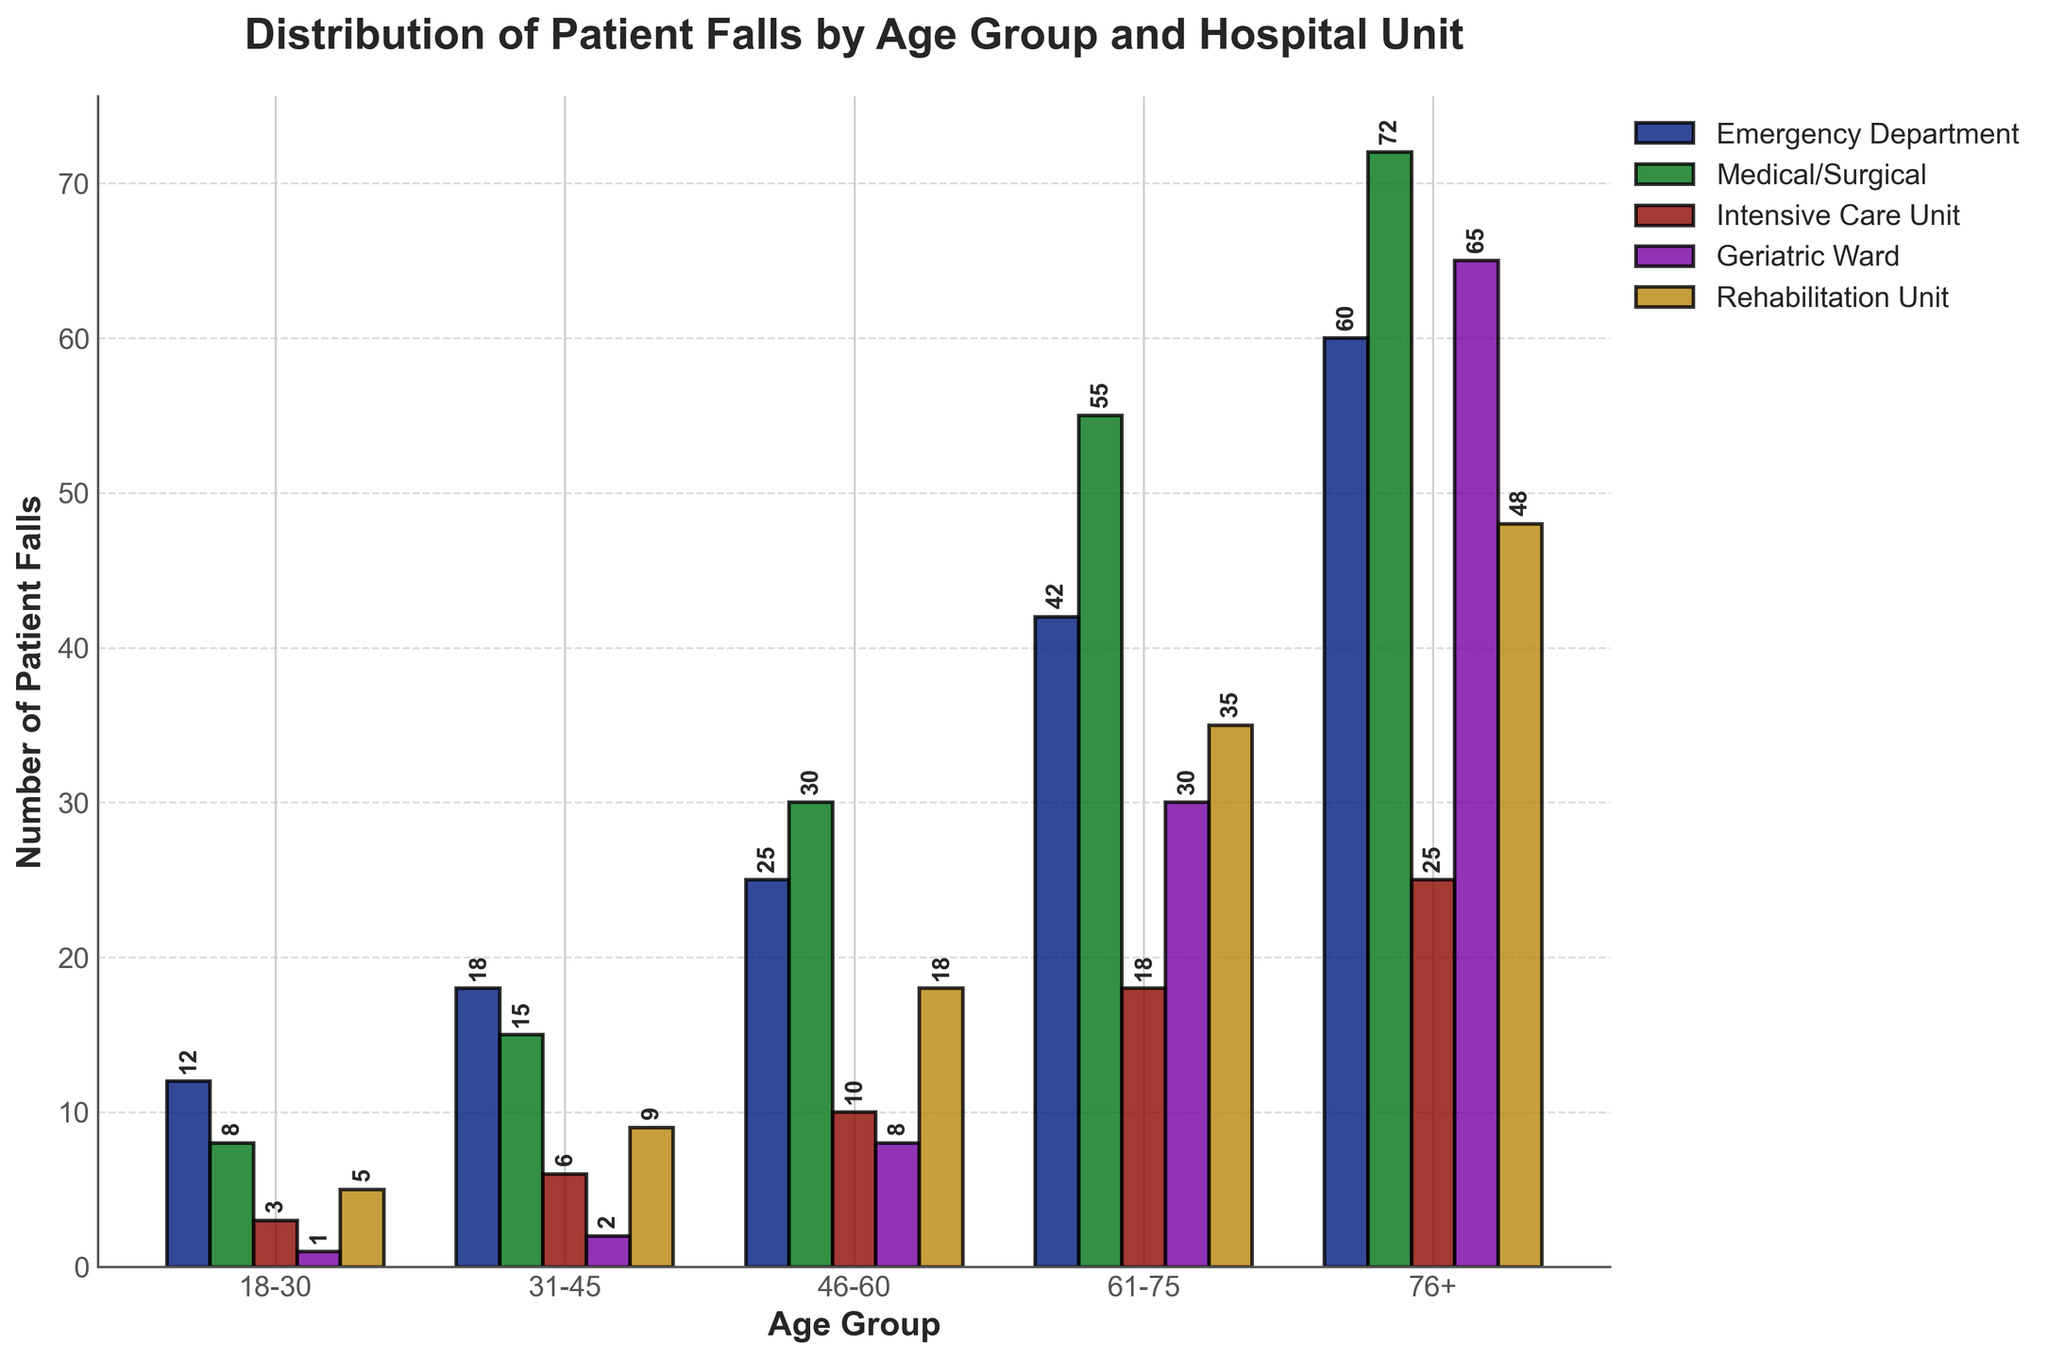What is the age group with the highest number of patient falls in the Emergency Department? To find the age group with the highest number of patient falls in the Emergency Department, look at the bars representing the Emergency Department for each age group and identify the one with the highest value. The bar for the 76+ age group is the highest at 60 falls.
Answer: 76+ Which hospital unit has the highest number of patient falls for the 61-75 age group? To determine which hospital unit has the highest number of patient falls for the 61-75 age group, compare the heights of the bars for the 61-75 age group across all hospital units. The bar for the Medical/Surgical unit is the highest at 55 falls.
Answer: Medical/Surgical How many total patient falls occurred in the Geriatric Ward? Sum the number of patient falls for the Geriatric Ward across all age groups: 1 (18-30) + 2 (31-45) + 8 (46-60) + 30 (61-75) + 65 (76+). The total is 106 falls.
Answer: 106 What is the difference in the number of patient falls between the 46-60 and 76+ age groups in the Rehabilitation Unit? To find the difference, subtract the number of patient falls for the 46-60 age group from the 76+ age group in the Rehabilitation Unit: 48 (76+) - 18 (46-60) = 30.
Answer: 30 Which age group has fewer falls in the Intensive Care Unit, 18-30 or 31-45? To determine this, compare the heights of the bars for the age groups 18-30 and 31-45 in the Intensive Care Unit. The 18-30 age group has 3 falls and the 31-45 age group has 6 falls.
Answer: 18-30 What is the total number of patient falls in the Medical/Surgical unit for age groups 18-30 and 31-45 combined? To find the total, add the number of patient falls in the Medical/Surgical unit for the age groups 18-30 and 31-45: 8 (18-30) + 15 (31-45) = 23.
Answer: 23 In which hospital unit is the proportion of patient falls by the 76+ age group highest? To determine the highest proportion of patient falls in the 76+ age group across different hospital units, visually compare the fraction of the total bar height for each unit that is attributed to the 76+ age group. The Geriatric Ward has the highest proportion as the bar for 76+ is significantly taller (65) compared to other age groups.
Answer: Geriatric Ward Which age group in the Rehabilitation Unit has the lowest number of patient falls? Compare the bar heights for each age group in the Rehabilitation Unit. The 18-30 age group has the lowest number of falls at 5.
Answer: 18-30 Between the Medical/Surgical and Intensive Care Unit, for the 61-75 age group, which one has more patient falls and by how much? Compare the number of falls in the Medical/Surgical unit (55) with those in the Intensive Care Unit (18) for the 61-75 age group. The Medical/Surgical unit has more by 55 - 18 = 37 falls.
Answer: Medical/Surgical, 37 What is the total number of patient falls across all age groups in the Intensive Care Unit? Sum the number of patient falls in the Intensive Care Unit for all age groups: 3 (18-30) + 6 (31-45) + 10 (46-60) + 18 (61-75) + 25 (76+). The total is 62 falls.
Answer: 62 